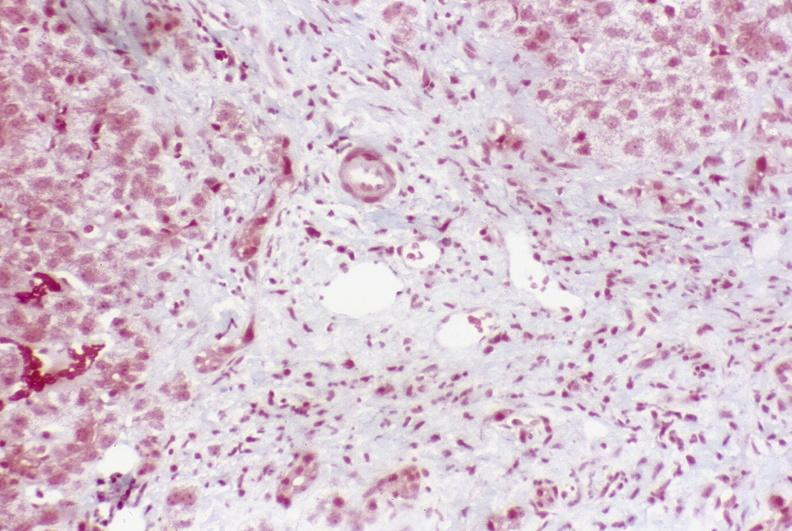what does this image show?
Answer the question using a single word or phrase. Primary sclerosing cholangitis 